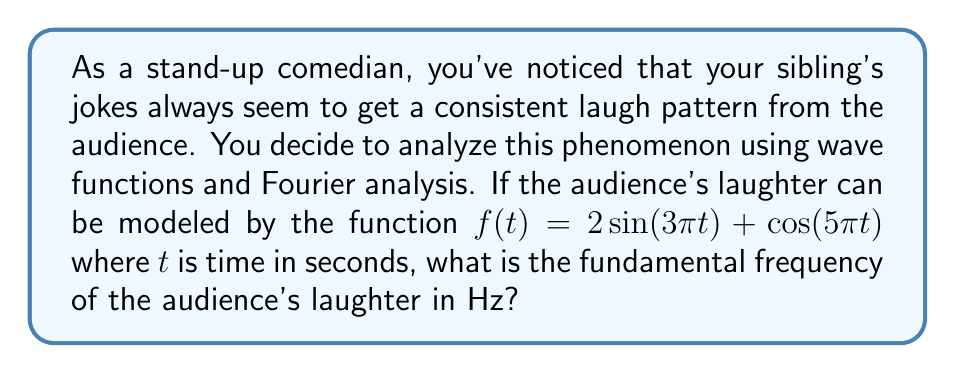Could you help me with this problem? Let's approach this step-by-step:

1) The given function is a combination of two sinusoidal waves:
   $f(t) = 2\sin(3\pi t) + \cos(5\pi t)$

2) In Fourier analysis, the fundamental frequency is the greatest common divisor (GCD) of the frequencies of the component waves.

3) For the first term, $2\sin(3\pi t)$:
   Frequency $f_1 = \frac{3\pi}{2\pi} = \frac{3}{2}$ Hz

4) For the second term, $\cos(5\pi t)$:
   Frequency $f_2 = \frac{5\pi}{2\pi} = \frac{5}{2}$ Hz

5) Now, we need to find the GCD of $\frac{3}{2}$ and $\frac{5}{2}$:

   $GCD(\frac{3}{2}, \frac{5}{2}) = \frac{1}{2} GCD(3, 5) = \frac{1}{2} \cdot 1 = \frac{1}{2}$

6) Therefore, the fundamental frequency is $\frac{1}{2}$ Hz.

This means the audience's laughter repeats its basic pattern every 2 seconds, which is quite a slow laugh - perfect for a deadpan delivery!
Answer: $\frac{1}{2}$ Hz 